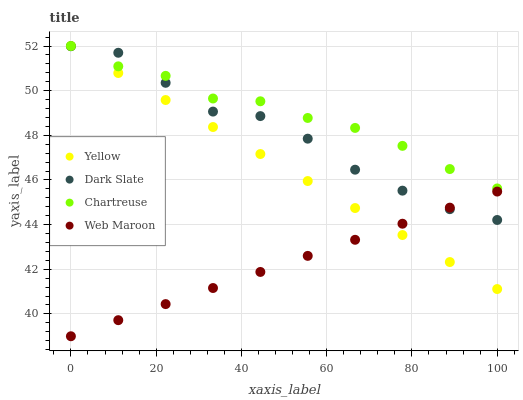Does Web Maroon have the minimum area under the curve?
Answer yes or no. Yes. Does Chartreuse have the maximum area under the curve?
Answer yes or no. Yes. Does Chartreuse have the minimum area under the curve?
Answer yes or no. No. Does Web Maroon have the maximum area under the curve?
Answer yes or no. No. Is Web Maroon the smoothest?
Answer yes or no. Yes. Is Dark Slate the roughest?
Answer yes or no. Yes. Is Chartreuse the smoothest?
Answer yes or no. No. Is Chartreuse the roughest?
Answer yes or no. No. Does Web Maroon have the lowest value?
Answer yes or no. Yes. Does Chartreuse have the lowest value?
Answer yes or no. No. Does Yellow have the highest value?
Answer yes or no. Yes. Does Web Maroon have the highest value?
Answer yes or no. No. Is Web Maroon less than Chartreuse?
Answer yes or no. Yes. Is Chartreuse greater than Web Maroon?
Answer yes or no. Yes. Does Dark Slate intersect Yellow?
Answer yes or no. Yes. Is Dark Slate less than Yellow?
Answer yes or no. No. Is Dark Slate greater than Yellow?
Answer yes or no. No. Does Web Maroon intersect Chartreuse?
Answer yes or no. No. 